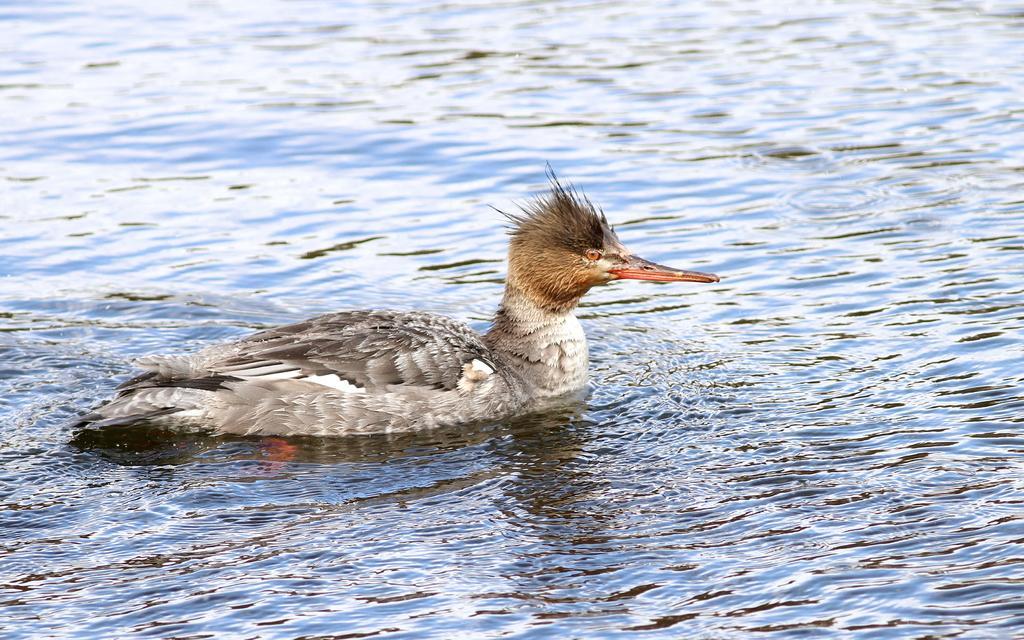Could you give a brief overview of what you see in this image? In the center of the image there is a duck in the water. 